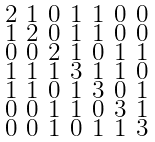Convert formula to latex. <formula><loc_0><loc_0><loc_500><loc_500>\begin{smallmatrix} 2 & 1 & 0 & 1 & 1 & 0 & 0 \\ 1 & 2 & 0 & 1 & 1 & 0 & 0 \\ 0 & 0 & 2 & 1 & 0 & 1 & 1 \\ 1 & 1 & 1 & 3 & 1 & 1 & 0 \\ 1 & 1 & 0 & 1 & 3 & 0 & 1 \\ 0 & 0 & 1 & 1 & 0 & 3 & 1 \\ 0 & 0 & 1 & 0 & 1 & 1 & 3 \end{smallmatrix}</formula> 